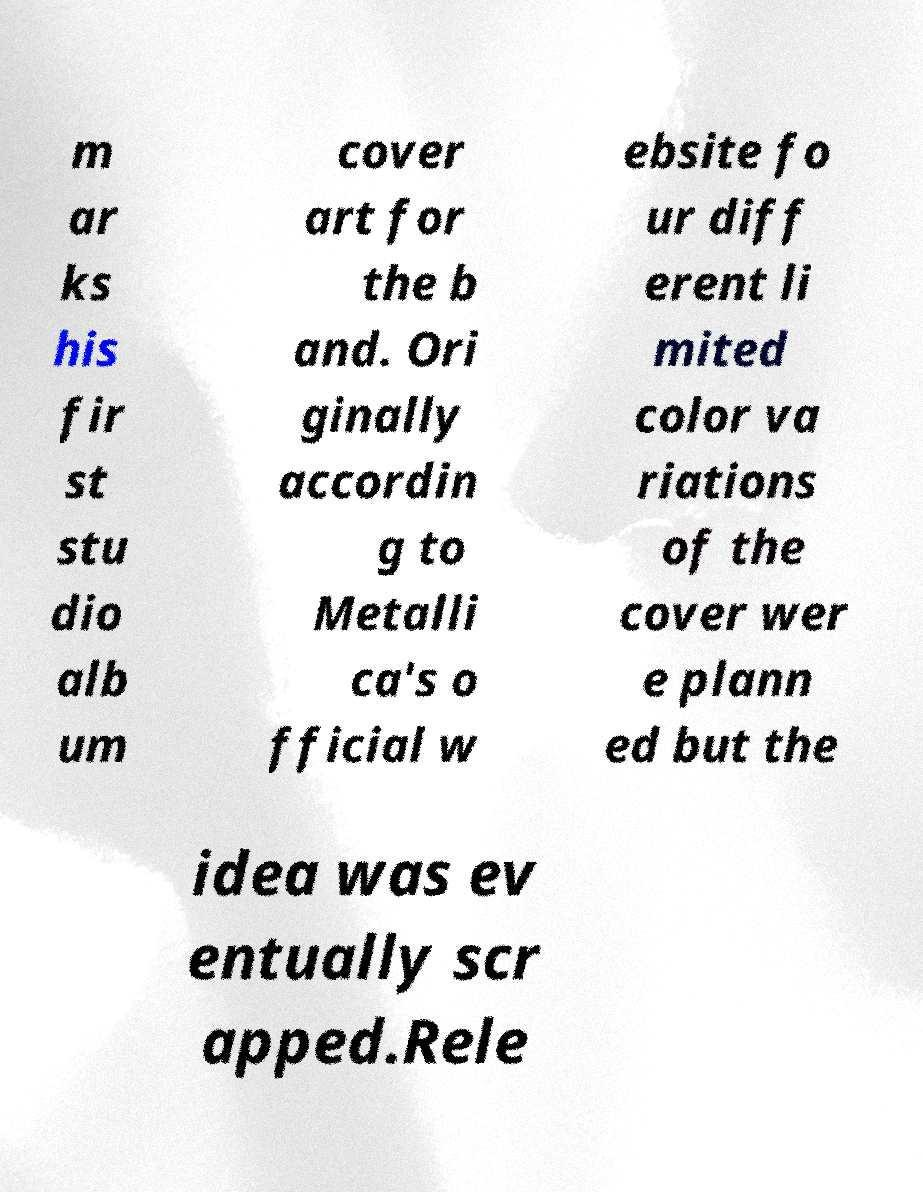Can you read and provide the text displayed in the image?This photo seems to have some interesting text. Can you extract and type it out for me? m ar ks his fir st stu dio alb um cover art for the b and. Ori ginally accordin g to Metalli ca's o fficial w ebsite fo ur diff erent li mited color va riations of the cover wer e plann ed but the idea was ev entually scr apped.Rele 